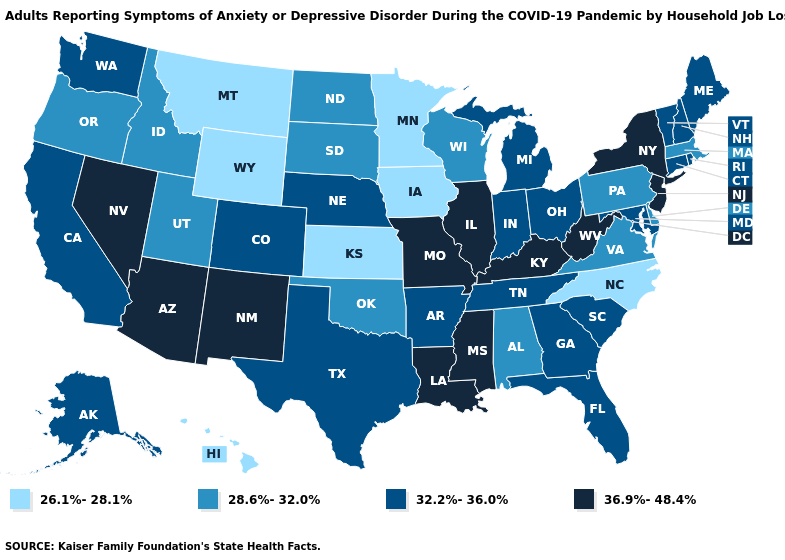What is the lowest value in the USA?
Write a very short answer. 26.1%-28.1%. Name the states that have a value in the range 32.2%-36.0%?
Quick response, please. Alaska, Arkansas, California, Colorado, Connecticut, Florida, Georgia, Indiana, Maine, Maryland, Michigan, Nebraska, New Hampshire, Ohio, Rhode Island, South Carolina, Tennessee, Texas, Vermont, Washington. Does California have the highest value in the USA?
Concise answer only. No. Which states have the lowest value in the West?
Be succinct. Hawaii, Montana, Wyoming. Which states have the lowest value in the USA?
Write a very short answer. Hawaii, Iowa, Kansas, Minnesota, Montana, North Carolina, Wyoming. Does New Jersey have the highest value in the Northeast?
Concise answer only. Yes. What is the lowest value in the USA?
Quick response, please. 26.1%-28.1%. Among the states that border Maryland , does Virginia have the highest value?
Quick response, please. No. What is the value of Missouri?
Keep it brief. 36.9%-48.4%. What is the highest value in the West ?
Be succinct. 36.9%-48.4%. Name the states that have a value in the range 26.1%-28.1%?
Concise answer only. Hawaii, Iowa, Kansas, Minnesota, Montana, North Carolina, Wyoming. What is the value of Connecticut?
Write a very short answer. 32.2%-36.0%. Does the first symbol in the legend represent the smallest category?
Quick response, please. Yes. Name the states that have a value in the range 32.2%-36.0%?
Give a very brief answer. Alaska, Arkansas, California, Colorado, Connecticut, Florida, Georgia, Indiana, Maine, Maryland, Michigan, Nebraska, New Hampshire, Ohio, Rhode Island, South Carolina, Tennessee, Texas, Vermont, Washington. Which states have the highest value in the USA?
Write a very short answer. Arizona, Illinois, Kentucky, Louisiana, Mississippi, Missouri, Nevada, New Jersey, New Mexico, New York, West Virginia. 